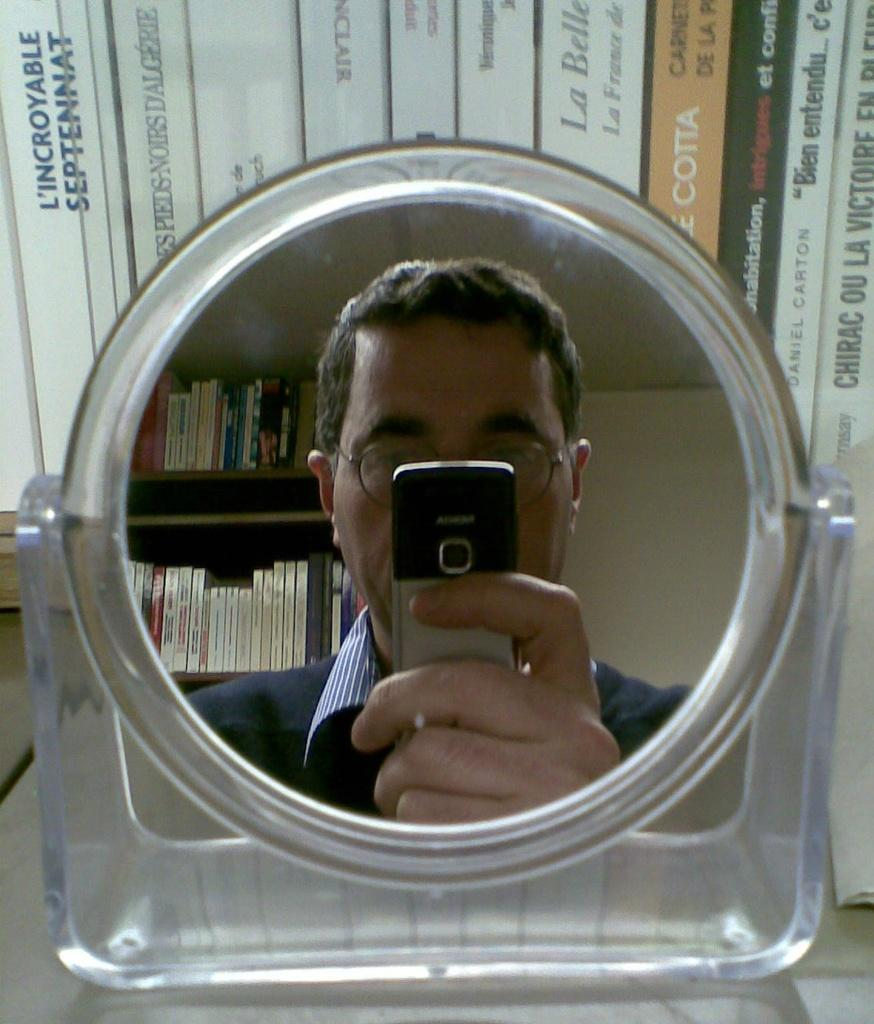What is the person in the image doing? The person in the image is sitting on a chair and reading a book. What is on the table in front of the person? There is a cup of coffee on the table. Can you describe the person's activity in more detail? The person is sitting on a chair, reading a book, and there is a cup of coffee on the table in front of them. What type of loaf can be seen in the image? There is no loaf present in the image. What shape is the cup of coffee in the image? The shape of the cup of coffee is not mentioned in the image, but it is likely a standard cup shape. 